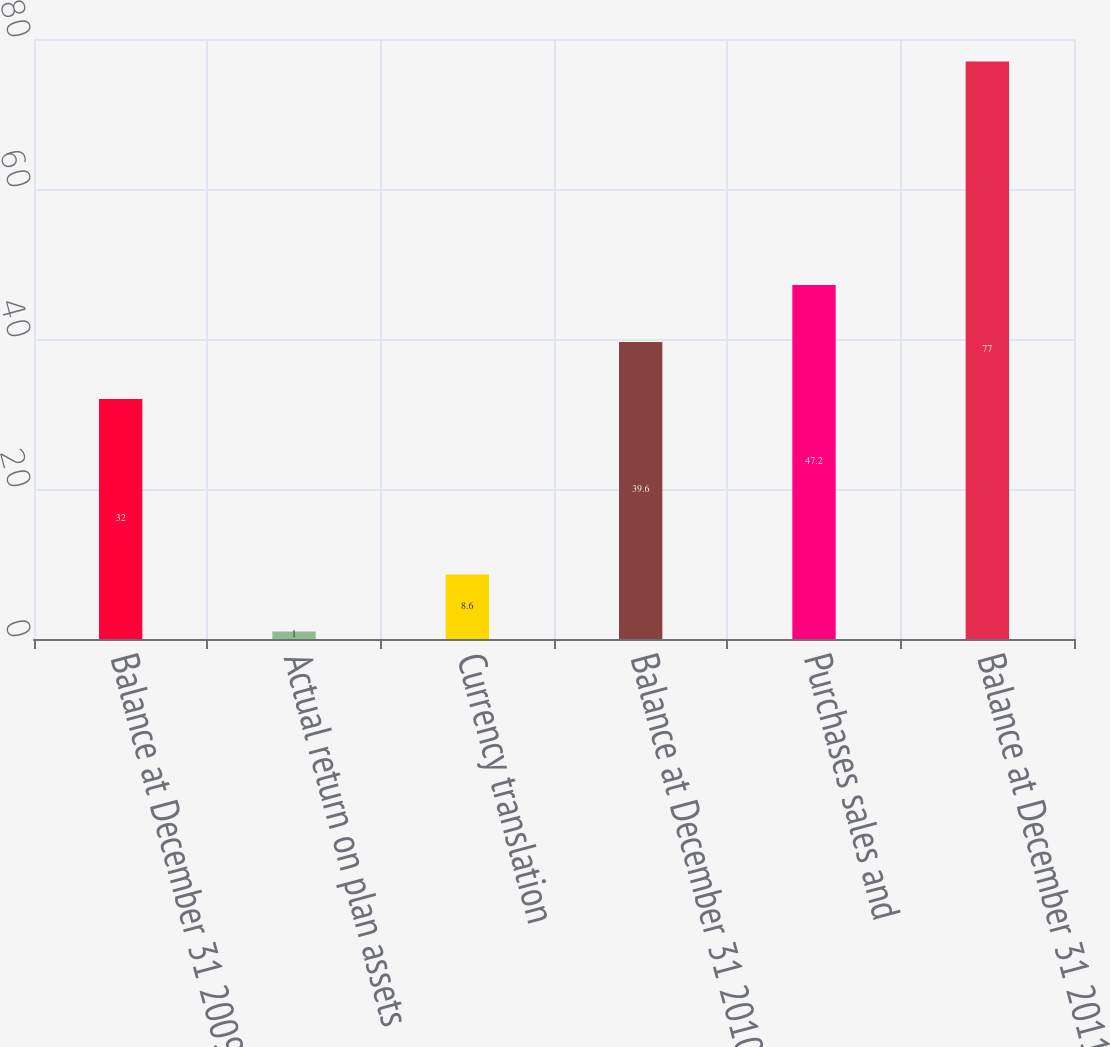Convert chart. <chart><loc_0><loc_0><loc_500><loc_500><bar_chart><fcel>Balance at December 31 2009<fcel>Actual return on plan assets<fcel>Currency translation<fcel>Balance at December 31 2010<fcel>Purchases sales and<fcel>Balance at December 31 2011<nl><fcel>32<fcel>1<fcel>8.6<fcel>39.6<fcel>47.2<fcel>77<nl></chart> 